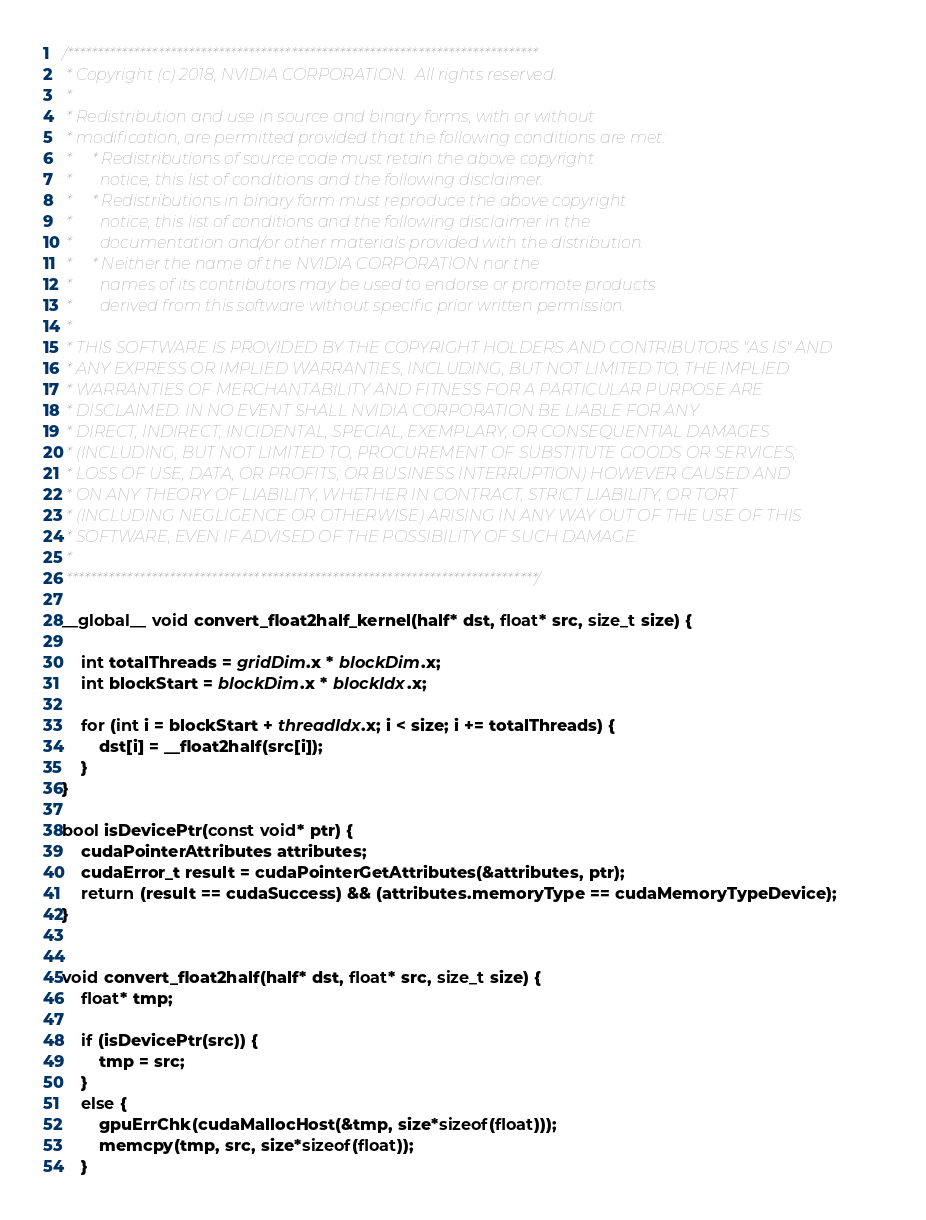<code> <loc_0><loc_0><loc_500><loc_500><_Cuda_>/******************************************************************************
 * Copyright (c) 2018, NVIDIA CORPORATION.  All rights reserved.
 *
 * Redistribution and use in source and binary forms, with or without
 * modification, are permitted provided that the following conditions are met:
 *     * Redistributions of source code must retain the above copyright
 *       notice, this list of conditions and the following disclaimer.
 *     * Redistributions in binary form must reproduce the above copyright
 *       notice, this list of conditions and the following disclaimer in the
 *       documentation and/or other materials provided with the distribution.
 *     * Neither the name of the NVIDIA CORPORATION nor the
 *       names of its contributors may be used to endorse or promote products
 *       derived from this software without specific prior written permission.
 *
 * THIS SOFTWARE IS PROVIDED BY THE COPYRIGHT HOLDERS AND CONTRIBUTORS "AS IS" AND
 * ANY EXPRESS OR IMPLIED WARRANTIES, INCLUDING, BUT NOT LIMITED TO, THE IMPLIED
 * WARRANTIES OF MERCHANTABILITY AND FITNESS FOR A PARTICULAR PURPOSE ARE
 * DISCLAIMED. IN NO EVENT SHALL NVIDIA CORPORATION BE LIABLE FOR ANY
 * DIRECT, INDIRECT, INCIDENTAL, SPECIAL, EXEMPLARY, OR CONSEQUENTIAL DAMAGES
 * (INCLUDING, BUT NOT LIMITED TO, PROCUREMENT OF SUBSTITUTE GOODS OR SERVICES;
 * LOSS OF USE, DATA, OR PROFITS; OR BUSINESS INTERRUPTION) HOWEVER CAUSED AND
 * ON ANY THEORY OF LIABILITY, WHETHER IN CONTRACT, STRICT LIABILITY, OR TORT
 * (INCLUDING NEGLIGENCE OR OTHERWISE) ARISING IN ANY WAY OUT OF THE USE OF THIS
 * SOFTWARE, EVEN IF ADVISED OF THE POSSIBILITY OF SUCH DAMAGE.
 *
 ******************************************************************************/

__global__ void convert_float2half_kernel(half* dst, float* src, size_t size) {

    int totalThreads = gridDim.x * blockDim.x;
    int blockStart = blockDim.x * blockIdx.x;

    for (int i = blockStart + threadIdx.x; i < size; i += totalThreads) {
        dst[i] = __float2half(src[i]);
    }
}

bool isDevicePtr(const void* ptr) {
    cudaPointerAttributes attributes;
    cudaError_t result = cudaPointerGetAttributes(&attributes, ptr);
    return (result == cudaSuccess) && (attributes.memoryType == cudaMemoryTypeDevice);
}


void convert_float2half(half* dst, float* src, size_t size) {
    float* tmp;

    if (isDevicePtr(src)) {
        tmp = src;
    }
    else {
        gpuErrChk(cudaMallocHost(&tmp, size*sizeof(float)));
        memcpy(tmp, src, size*sizeof(float));
    }
</code> 